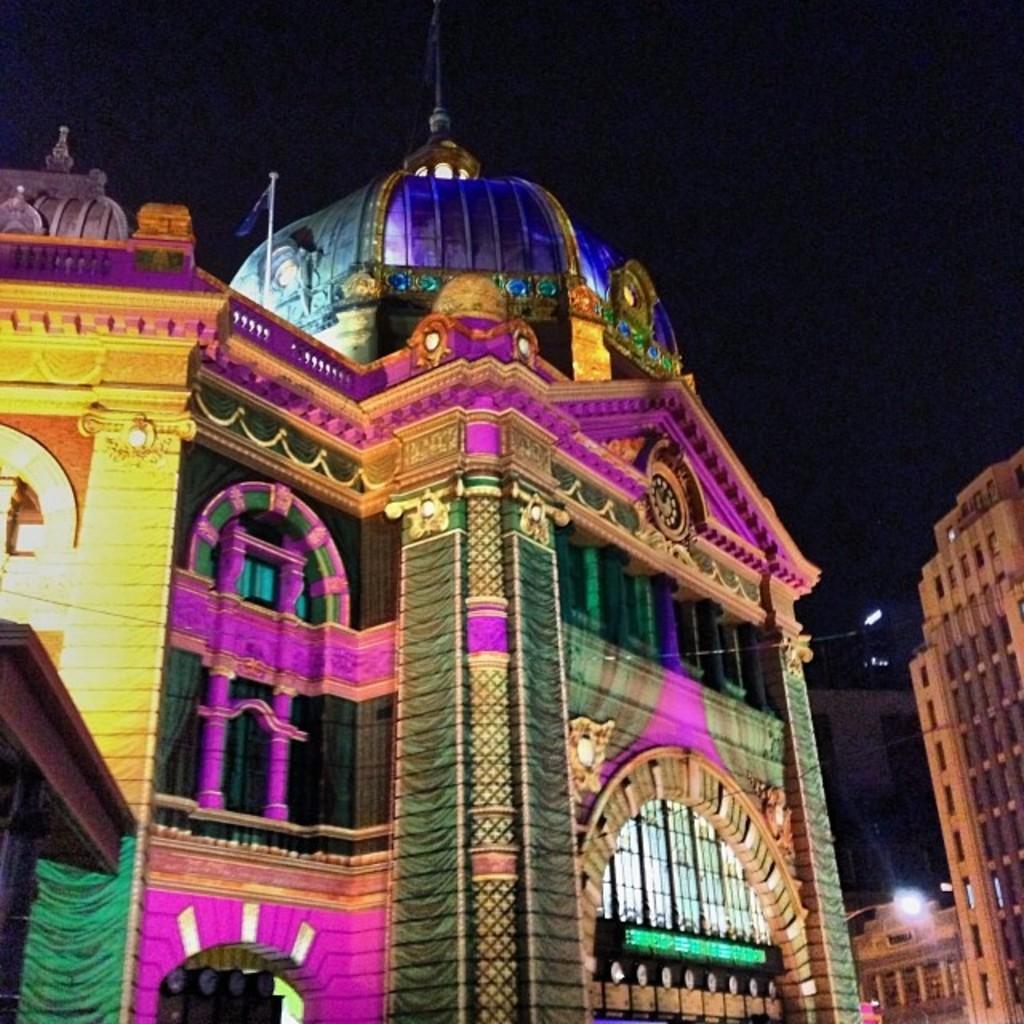In one or two sentences, can you explain what this image depicts? In this image we can see buildings. This building is colorful. 